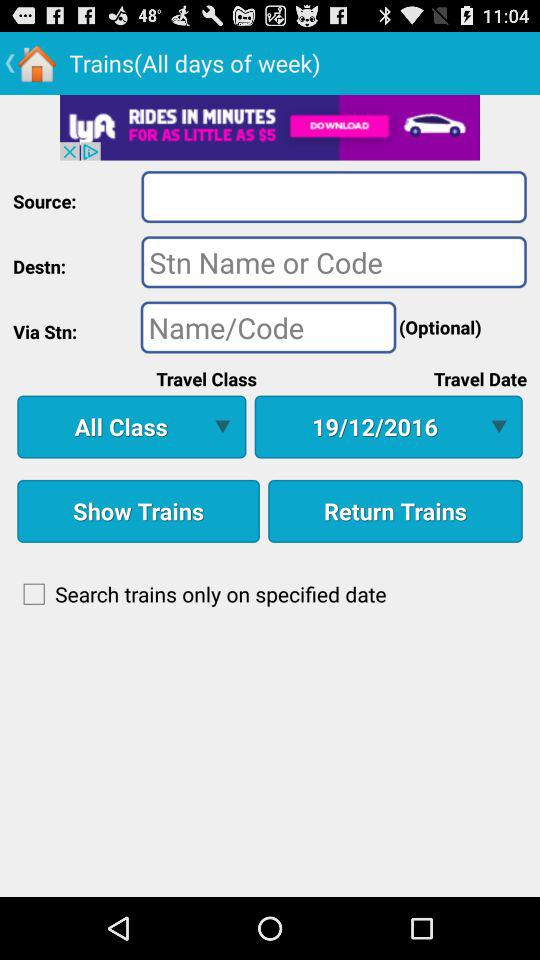How many checkboxes are on the screen?
Answer the question using a single word or phrase. 1 